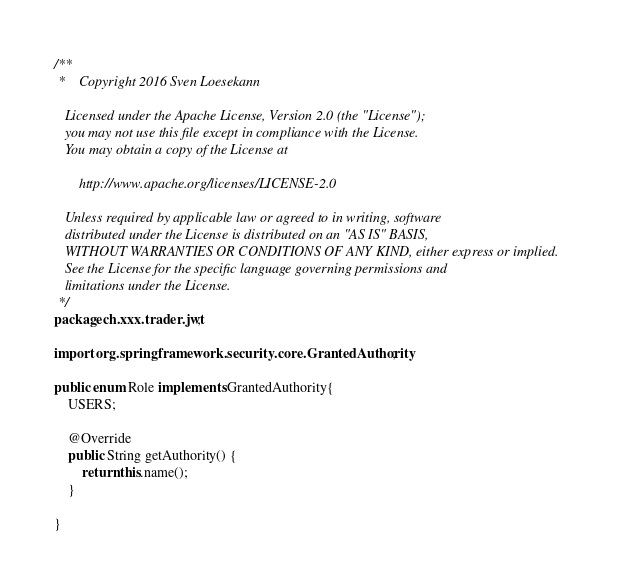Convert code to text. <code><loc_0><loc_0><loc_500><loc_500><_Java_>/**
 *    Copyright 2016 Sven Loesekann

   Licensed under the Apache License, Version 2.0 (the "License");
   you may not use this file except in compliance with the License.
   You may obtain a copy of the License at

       http://www.apache.org/licenses/LICENSE-2.0

   Unless required by applicable law or agreed to in writing, software
   distributed under the License is distributed on an "AS IS" BASIS,
   WITHOUT WARRANTIES OR CONDITIONS OF ANY KIND, either express or implied.
   See the License for the specific language governing permissions and
   limitations under the License.
 */
package ch.xxx.trader.jwt;

import org.springframework.security.core.GrantedAuthority;

public enum Role implements GrantedAuthority{
	USERS;

	@Override
	public String getAuthority() {		
		return this.name();
	}
	
}
</code> 